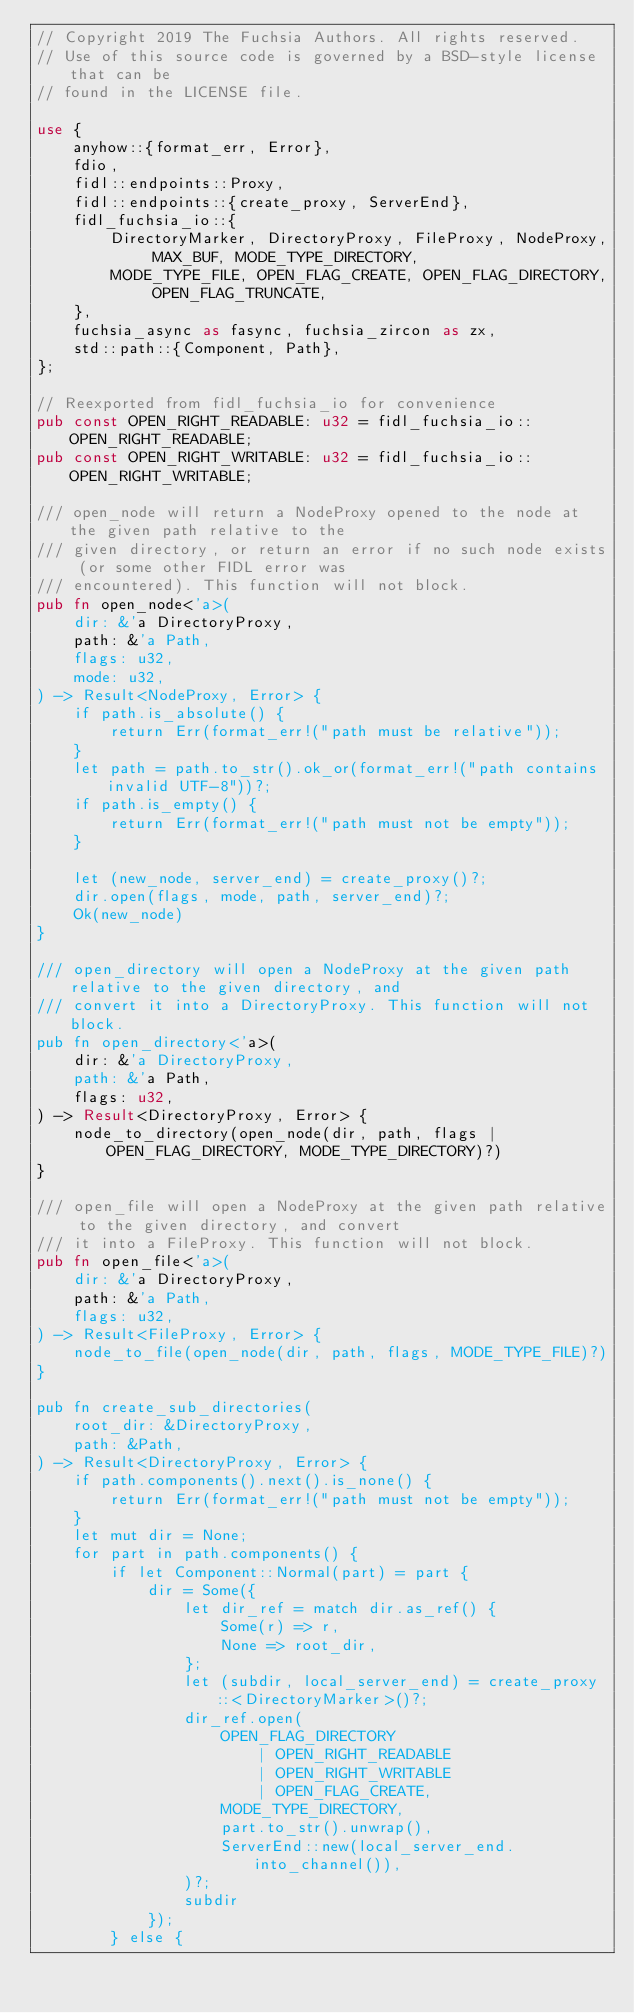Convert code to text. <code><loc_0><loc_0><loc_500><loc_500><_Rust_>// Copyright 2019 The Fuchsia Authors. All rights reserved.
// Use of this source code is governed by a BSD-style license that can be
// found in the LICENSE file.

use {
    anyhow::{format_err, Error},
    fdio,
    fidl::endpoints::Proxy,
    fidl::endpoints::{create_proxy, ServerEnd},
    fidl_fuchsia_io::{
        DirectoryMarker, DirectoryProxy, FileProxy, NodeProxy, MAX_BUF, MODE_TYPE_DIRECTORY,
        MODE_TYPE_FILE, OPEN_FLAG_CREATE, OPEN_FLAG_DIRECTORY, OPEN_FLAG_TRUNCATE,
    },
    fuchsia_async as fasync, fuchsia_zircon as zx,
    std::path::{Component, Path},
};

// Reexported from fidl_fuchsia_io for convenience
pub const OPEN_RIGHT_READABLE: u32 = fidl_fuchsia_io::OPEN_RIGHT_READABLE;
pub const OPEN_RIGHT_WRITABLE: u32 = fidl_fuchsia_io::OPEN_RIGHT_WRITABLE;

/// open_node will return a NodeProxy opened to the node at the given path relative to the
/// given directory, or return an error if no such node exists (or some other FIDL error was
/// encountered). This function will not block.
pub fn open_node<'a>(
    dir: &'a DirectoryProxy,
    path: &'a Path,
    flags: u32,
    mode: u32,
) -> Result<NodeProxy, Error> {
    if path.is_absolute() {
        return Err(format_err!("path must be relative"));
    }
    let path = path.to_str().ok_or(format_err!("path contains invalid UTF-8"))?;
    if path.is_empty() {
        return Err(format_err!("path must not be empty"));
    }

    let (new_node, server_end) = create_proxy()?;
    dir.open(flags, mode, path, server_end)?;
    Ok(new_node)
}

/// open_directory will open a NodeProxy at the given path relative to the given directory, and
/// convert it into a DirectoryProxy. This function will not block.
pub fn open_directory<'a>(
    dir: &'a DirectoryProxy,
    path: &'a Path,
    flags: u32,
) -> Result<DirectoryProxy, Error> {
    node_to_directory(open_node(dir, path, flags | OPEN_FLAG_DIRECTORY, MODE_TYPE_DIRECTORY)?)
}

/// open_file will open a NodeProxy at the given path relative to the given directory, and convert
/// it into a FileProxy. This function will not block.
pub fn open_file<'a>(
    dir: &'a DirectoryProxy,
    path: &'a Path,
    flags: u32,
) -> Result<FileProxy, Error> {
    node_to_file(open_node(dir, path, flags, MODE_TYPE_FILE)?)
}

pub fn create_sub_directories(
    root_dir: &DirectoryProxy,
    path: &Path,
) -> Result<DirectoryProxy, Error> {
    if path.components().next().is_none() {
        return Err(format_err!("path must not be empty"));
    }
    let mut dir = None;
    for part in path.components() {
        if let Component::Normal(part) = part {
            dir = Some({
                let dir_ref = match dir.as_ref() {
                    Some(r) => r,
                    None => root_dir,
                };
                let (subdir, local_server_end) = create_proxy::<DirectoryMarker>()?;
                dir_ref.open(
                    OPEN_FLAG_DIRECTORY
                        | OPEN_RIGHT_READABLE
                        | OPEN_RIGHT_WRITABLE
                        | OPEN_FLAG_CREATE,
                    MODE_TYPE_DIRECTORY,
                    part.to_str().unwrap(),
                    ServerEnd::new(local_server_end.into_channel()),
                )?;
                subdir
            });
        } else {</code> 